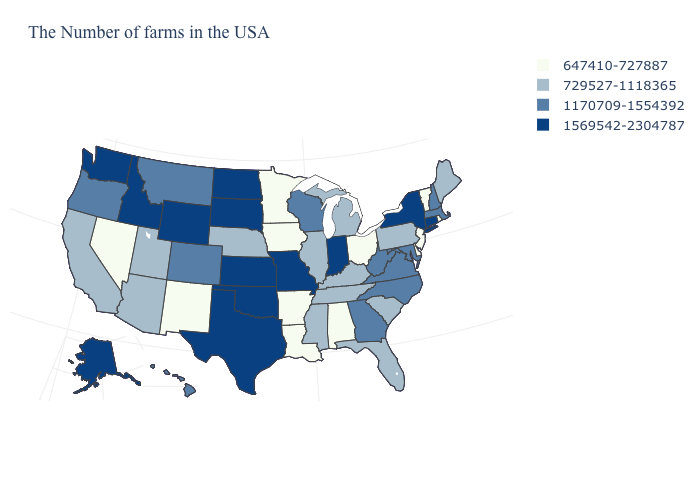Does Ohio have the lowest value in the MidWest?
Answer briefly. Yes. What is the value of Utah?
Write a very short answer. 729527-1118365. Does Missouri have a higher value than Indiana?
Short answer required. No. How many symbols are there in the legend?
Answer briefly. 4. Name the states that have a value in the range 1170709-1554392?
Quick response, please. Massachusetts, New Hampshire, Maryland, Virginia, North Carolina, West Virginia, Georgia, Wisconsin, Colorado, Montana, Oregon, Hawaii. What is the highest value in the West ?
Answer briefly. 1569542-2304787. What is the value of Kansas?
Short answer required. 1569542-2304787. Name the states that have a value in the range 1569542-2304787?
Give a very brief answer. Connecticut, New York, Indiana, Missouri, Kansas, Oklahoma, Texas, South Dakota, North Dakota, Wyoming, Idaho, Washington, Alaska. What is the value of North Carolina?
Write a very short answer. 1170709-1554392. What is the value of Maryland?
Be succinct. 1170709-1554392. What is the value of Wyoming?
Answer briefly. 1569542-2304787. What is the lowest value in states that border New York?
Give a very brief answer. 647410-727887. Name the states that have a value in the range 1569542-2304787?
Keep it brief. Connecticut, New York, Indiana, Missouri, Kansas, Oklahoma, Texas, South Dakota, North Dakota, Wyoming, Idaho, Washington, Alaska. Does Rhode Island have a lower value than Alabama?
Keep it brief. No. Name the states that have a value in the range 729527-1118365?
Keep it brief. Maine, Pennsylvania, South Carolina, Florida, Michigan, Kentucky, Tennessee, Illinois, Mississippi, Nebraska, Utah, Arizona, California. 